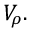<formula> <loc_0><loc_0><loc_500><loc_500>V _ { \rho } .</formula> 